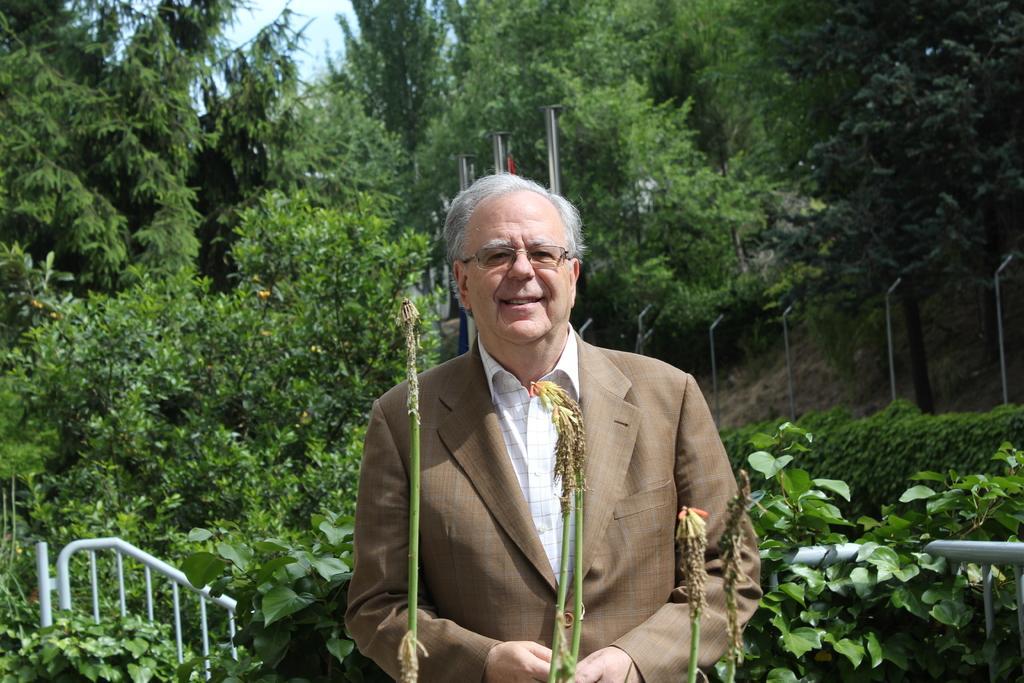Describe this image in one or two sentences. In this image we can see a man standing between the plants. In the background there are trees, sky, iron grills and poles. 